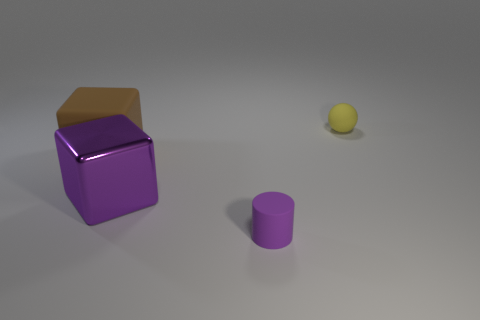Is there any other thing that has the same shape as the tiny yellow thing?
Provide a short and direct response. No. What number of things are small objects that are on the right side of the tiny purple thing or small objects that are behind the purple metal cube?
Give a very brief answer. 1. What is the shape of the yellow rubber object that is the same size as the purple matte object?
Keep it short and to the point. Sphere. The cube that is made of the same material as the tiny purple cylinder is what size?
Your answer should be compact. Large. Is the metallic thing the same shape as the small yellow matte object?
Provide a succinct answer. No. What color is the ball that is the same size as the cylinder?
Offer a very short reply. Yellow. There is a purple thing that is the same shape as the brown thing; what is its size?
Offer a terse response. Large. What is the shape of the tiny matte thing that is on the left side of the rubber sphere?
Make the answer very short. Cylinder. There is a tiny yellow matte object; is its shape the same as the tiny thing on the left side of the yellow thing?
Keep it short and to the point. No. Are there the same number of yellow matte objects to the left of the purple metallic cube and purple rubber objects that are behind the yellow matte object?
Provide a short and direct response. Yes. 